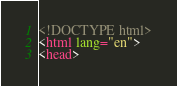<code> <loc_0><loc_0><loc_500><loc_500><_HTML_>
<!DOCTYPE html>
<html lang="en">
<head></code> 